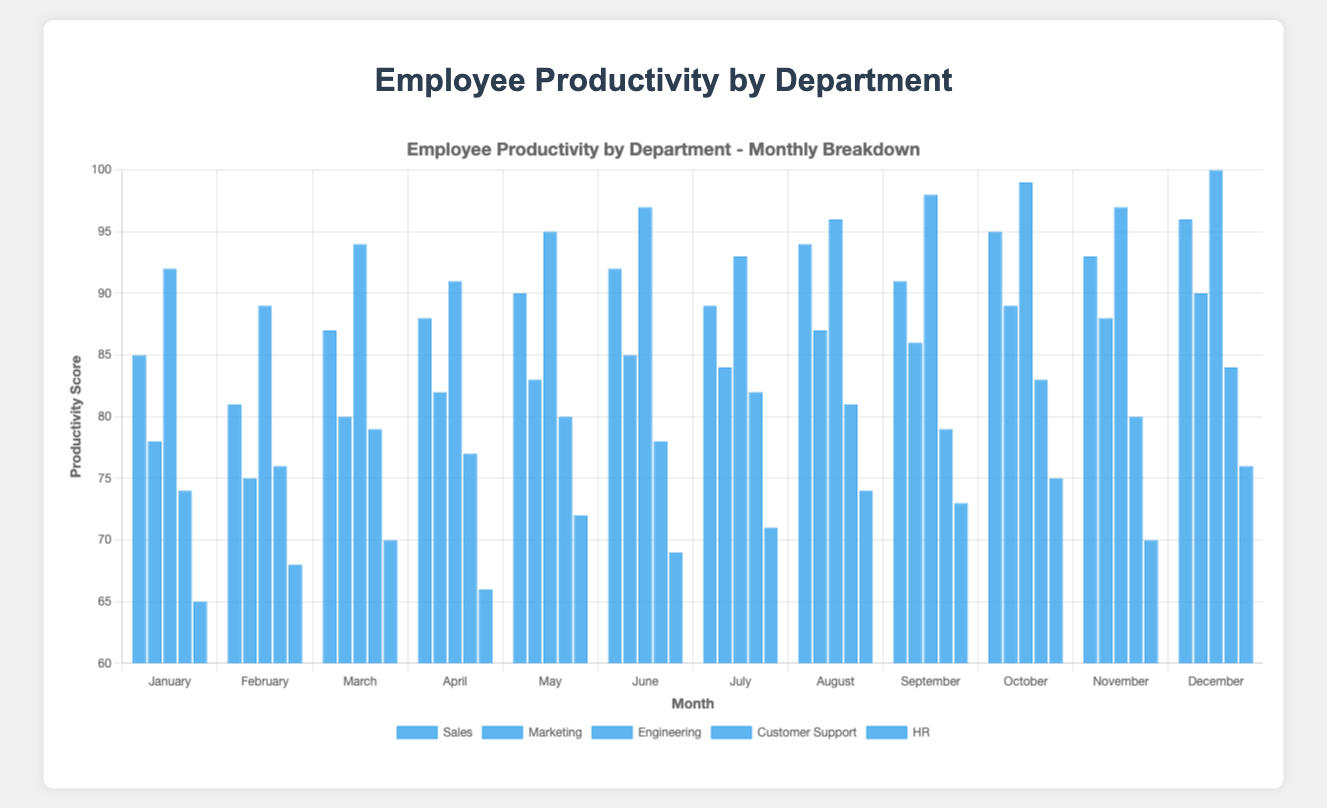What was the highest productivity score in Engineering throughout the year? The monthly productivity scores for Engineering are [92, 89, 94, 91, 95, 97, 93, 96, 98, 99, 97, 100]. The highest value among these is 100, which occurred in December.
Answer: 100 In which month did Sales have its lowest productivity score? The monthly productivity scores for Sales are [85, 81, 87, 88, 90, 92, 89, 94, 91, 95, 93, 96]. The lowest value among these is 81, which occurred in February.
Answer: February How does HR's productivity in June compare to Customer Support's productivity in the same month? In June, HR’s productivity score was 69, while Customer Support's score was 78. Thus, Customer Support's productivity was higher compared to HR's.
Answer: Customer Support is higher What is the average productivity score for Marketing in the last quarter (October, November, December)? The scores for Marketing in October, November, and December are 89, 88, and 90, respectively. The sum of these values is 267, and there are 3 months. Hence, the average score is 267/3 = 89.
Answer: 89 Which department had the most consistent productivity score over the year, and how did it vary? The variation in each department's monthly productivity scores is as follows:<br> Sales: 85-96 (range 11), Marketing: 75-90 (range 15), Engineering: 89-100 (range 11), Customer Support: 74-84 (range 10), HR: 65-76 (range 11). The department with the smallest range is Customer Support, showing it had the most consistent productivity score.
Answer: Customer Support What is the difference between the highest and lowest productivity scores across all departments in December? In December, the productivity scores are Sales: 96, Marketing: 90, Engineering: 100, Customer Support: 84, HR: 76. The highest score is 100, and the lowest score is 76. The difference is 100 - 76 = 24.
Answer: 24 Which two departments had the closest productivity scores in September, and what were the scores? In September, the productivity scores are Sales: 91, Marketing: 86, Engineering: 98, Customer Support: 79, HR: 73. The closest scores are between HR (73) and Customer Support (79), with a difference of 6 points.
Answer: HR and Customer Support (73 and 79) What is the total productivity score of Sales over the first half of the year (January to June)? The monthly productivity scores for Sales from January to June are [85, 81, 87, 88, 90, 92]. The total is the sum of these values: 85 + 81 + 87 + 88 + 90 + 92 = 523.
Answer: 523 